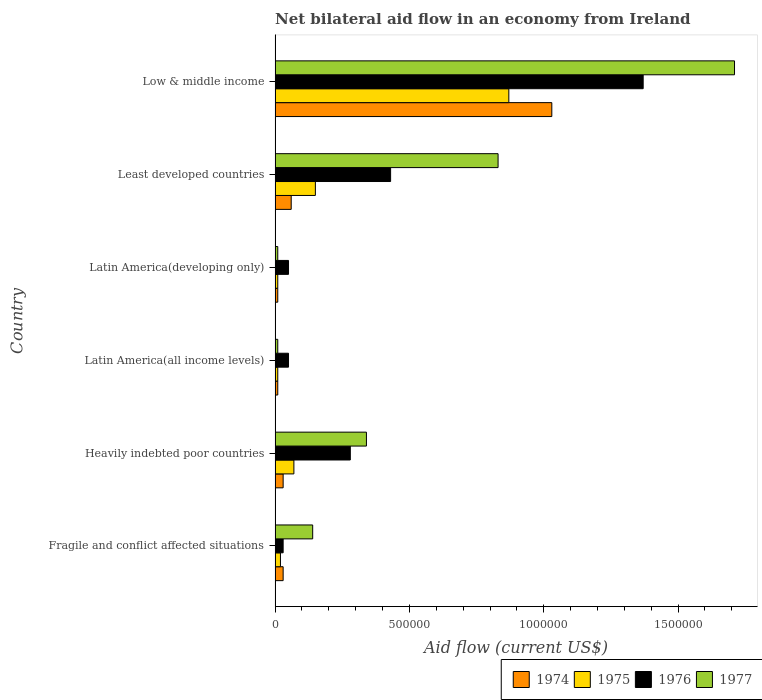How many different coloured bars are there?
Your response must be concise. 4. Are the number of bars per tick equal to the number of legend labels?
Keep it short and to the point. Yes. What is the label of the 1st group of bars from the top?
Provide a succinct answer. Low & middle income. In how many cases, is the number of bars for a given country not equal to the number of legend labels?
Your answer should be compact. 0. Across all countries, what is the maximum net bilateral aid flow in 1974?
Your response must be concise. 1.03e+06. In which country was the net bilateral aid flow in 1977 maximum?
Provide a succinct answer. Low & middle income. In which country was the net bilateral aid flow in 1977 minimum?
Provide a short and direct response. Latin America(all income levels). What is the total net bilateral aid flow in 1977 in the graph?
Ensure brevity in your answer.  3.04e+06. What is the difference between the net bilateral aid flow in 1976 in Fragile and conflict affected situations and that in Least developed countries?
Your answer should be very brief. -4.00e+05. What is the difference between the net bilateral aid flow in 1977 in Latin America(all income levels) and the net bilateral aid flow in 1974 in Least developed countries?
Your response must be concise. -5.00e+04. What is the average net bilateral aid flow in 1976 per country?
Offer a very short reply. 3.68e+05. What is the difference between the net bilateral aid flow in 1977 and net bilateral aid flow in 1975 in Low & middle income?
Give a very brief answer. 8.40e+05. What is the ratio of the net bilateral aid flow in 1974 in Fragile and conflict affected situations to that in Low & middle income?
Make the answer very short. 0.03. Is the net bilateral aid flow in 1976 in Heavily indebted poor countries less than that in Low & middle income?
Offer a very short reply. Yes. What is the difference between the highest and the second highest net bilateral aid flow in 1977?
Provide a succinct answer. 8.80e+05. What is the difference between the highest and the lowest net bilateral aid flow in 1976?
Make the answer very short. 1.34e+06. Is it the case that in every country, the sum of the net bilateral aid flow in 1976 and net bilateral aid flow in 1975 is greater than the sum of net bilateral aid flow in 1974 and net bilateral aid flow in 1977?
Your answer should be very brief. No. What does the 4th bar from the top in Low & middle income represents?
Offer a very short reply. 1974. What does the 3rd bar from the bottom in Fragile and conflict affected situations represents?
Ensure brevity in your answer.  1976. Are all the bars in the graph horizontal?
Provide a succinct answer. Yes. How many countries are there in the graph?
Make the answer very short. 6. What is the difference between two consecutive major ticks on the X-axis?
Provide a short and direct response. 5.00e+05. Are the values on the major ticks of X-axis written in scientific E-notation?
Keep it short and to the point. No. Does the graph contain any zero values?
Your answer should be very brief. No. What is the title of the graph?
Give a very brief answer. Net bilateral aid flow in an economy from Ireland. Does "1981" appear as one of the legend labels in the graph?
Your answer should be very brief. No. What is the Aid flow (current US$) in 1974 in Fragile and conflict affected situations?
Your answer should be compact. 3.00e+04. What is the Aid flow (current US$) of 1977 in Fragile and conflict affected situations?
Your response must be concise. 1.40e+05. What is the Aid flow (current US$) of 1974 in Heavily indebted poor countries?
Offer a terse response. 3.00e+04. What is the Aid flow (current US$) of 1975 in Heavily indebted poor countries?
Offer a very short reply. 7.00e+04. What is the Aid flow (current US$) of 1977 in Heavily indebted poor countries?
Offer a very short reply. 3.40e+05. What is the Aid flow (current US$) in 1974 in Latin America(all income levels)?
Ensure brevity in your answer.  10000. What is the Aid flow (current US$) in 1976 in Latin America(all income levels)?
Your answer should be very brief. 5.00e+04. What is the Aid flow (current US$) in 1977 in Latin America(all income levels)?
Give a very brief answer. 10000. What is the Aid flow (current US$) in 1974 in Latin America(developing only)?
Your answer should be very brief. 10000. What is the Aid flow (current US$) of 1975 in Latin America(developing only)?
Make the answer very short. 10000. What is the Aid flow (current US$) in 1977 in Latin America(developing only)?
Make the answer very short. 10000. What is the Aid flow (current US$) of 1975 in Least developed countries?
Provide a succinct answer. 1.50e+05. What is the Aid flow (current US$) in 1976 in Least developed countries?
Keep it short and to the point. 4.30e+05. What is the Aid flow (current US$) in 1977 in Least developed countries?
Make the answer very short. 8.30e+05. What is the Aid flow (current US$) of 1974 in Low & middle income?
Ensure brevity in your answer.  1.03e+06. What is the Aid flow (current US$) in 1975 in Low & middle income?
Offer a very short reply. 8.70e+05. What is the Aid flow (current US$) in 1976 in Low & middle income?
Your answer should be very brief. 1.37e+06. What is the Aid flow (current US$) in 1977 in Low & middle income?
Provide a short and direct response. 1.71e+06. Across all countries, what is the maximum Aid flow (current US$) in 1974?
Your answer should be compact. 1.03e+06. Across all countries, what is the maximum Aid flow (current US$) in 1975?
Your answer should be very brief. 8.70e+05. Across all countries, what is the maximum Aid flow (current US$) of 1976?
Your answer should be very brief. 1.37e+06. Across all countries, what is the maximum Aid flow (current US$) of 1977?
Provide a succinct answer. 1.71e+06. Across all countries, what is the minimum Aid flow (current US$) in 1976?
Your response must be concise. 3.00e+04. Across all countries, what is the minimum Aid flow (current US$) of 1977?
Offer a terse response. 10000. What is the total Aid flow (current US$) of 1974 in the graph?
Your response must be concise. 1.17e+06. What is the total Aid flow (current US$) in 1975 in the graph?
Provide a succinct answer. 1.13e+06. What is the total Aid flow (current US$) in 1976 in the graph?
Offer a terse response. 2.21e+06. What is the total Aid flow (current US$) in 1977 in the graph?
Your response must be concise. 3.04e+06. What is the difference between the Aid flow (current US$) of 1977 in Fragile and conflict affected situations and that in Heavily indebted poor countries?
Ensure brevity in your answer.  -2.00e+05. What is the difference between the Aid flow (current US$) of 1974 in Fragile and conflict affected situations and that in Latin America(all income levels)?
Your answer should be compact. 2.00e+04. What is the difference between the Aid flow (current US$) of 1975 in Fragile and conflict affected situations and that in Latin America(all income levels)?
Offer a terse response. 10000. What is the difference between the Aid flow (current US$) in 1976 in Fragile and conflict affected situations and that in Latin America(all income levels)?
Provide a short and direct response. -2.00e+04. What is the difference between the Aid flow (current US$) of 1976 in Fragile and conflict affected situations and that in Latin America(developing only)?
Provide a short and direct response. -2.00e+04. What is the difference between the Aid flow (current US$) in 1975 in Fragile and conflict affected situations and that in Least developed countries?
Make the answer very short. -1.30e+05. What is the difference between the Aid flow (current US$) of 1976 in Fragile and conflict affected situations and that in Least developed countries?
Provide a short and direct response. -4.00e+05. What is the difference between the Aid flow (current US$) of 1977 in Fragile and conflict affected situations and that in Least developed countries?
Make the answer very short. -6.90e+05. What is the difference between the Aid flow (current US$) in 1975 in Fragile and conflict affected situations and that in Low & middle income?
Offer a terse response. -8.50e+05. What is the difference between the Aid flow (current US$) of 1976 in Fragile and conflict affected situations and that in Low & middle income?
Your response must be concise. -1.34e+06. What is the difference between the Aid flow (current US$) of 1977 in Fragile and conflict affected situations and that in Low & middle income?
Your answer should be compact. -1.57e+06. What is the difference between the Aid flow (current US$) in 1974 in Heavily indebted poor countries and that in Latin America(all income levels)?
Offer a terse response. 2.00e+04. What is the difference between the Aid flow (current US$) in 1976 in Heavily indebted poor countries and that in Latin America(all income levels)?
Make the answer very short. 2.30e+05. What is the difference between the Aid flow (current US$) of 1977 in Heavily indebted poor countries and that in Latin America(all income levels)?
Provide a short and direct response. 3.30e+05. What is the difference between the Aid flow (current US$) in 1975 in Heavily indebted poor countries and that in Latin America(developing only)?
Your answer should be very brief. 6.00e+04. What is the difference between the Aid flow (current US$) in 1976 in Heavily indebted poor countries and that in Latin America(developing only)?
Offer a terse response. 2.30e+05. What is the difference between the Aid flow (current US$) in 1977 in Heavily indebted poor countries and that in Least developed countries?
Keep it short and to the point. -4.90e+05. What is the difference between the Aid flow (current US$) of 1974 in Heavily indebted poor countries and that in Low & middle income?
Provide a short and direct response. -1.00e+06. What is the difference between the Aid flow (current US$) in 1975 in Heavily indebted poor countries and that in Low & middle income?
Provide a short and direct response. -8.00e+05. What is the difference between the Aid flow (current US$) in 1976 in Heavily indebted poor countries and that in Low & middle income?
Ensure brevity in your answer.  -1.09e+06. What is the difference between the Aid flow (current US$) in 1977 in Heavily indebted poor countries and that in Low & middle income?
Your response must be concise. -1.37e+06. What is the difference between the Aid flow (current US$) in 1974 in Latin America(all income levels) and that in Latin America(developing only)?
Make the answer very short. 0. What is the difference between the Aid flow (current US$) in 1975 in Latin America(all income levels) and that in Latin America(developing only)?
Offer a very short reply. 0. What is the difference between the Aid flow (current US$) of 1974 in Latin America(all income levels) and that in Least developed countries?
Keep it short and to the point. -5.00e+04. What is the difference between the Aid flow (current US$) in 1975 in Latin America(all income levels) and that in Least developed countries?
Your response must be concise. -1.40e+05. What is the difference between the Aid flow (current US$) of 1976 in Latin America(all income levels) and that in Least developed countries?
Ensure brevity in your answer.  -3.80e+05. What is the difference between the Aid flow (current US$) of 1977 in Latin America(all income levels) and that in Least developed countries?
Provide a short and direct response. -8.20e+05. What is the difference between the Aid flow (current US$) in 1974 in Latin America(all income levels) and that in Low & middle income?
Offer a terse response. -1.02e+06. What is the difference between the Aid flow (current US$) in 1975 in Latin America(all income levels) and that in Low & middle income?
Provide a short and direct response. -8.60e+05. What is the difference between the Aid flow (current US$) of 1976 in Latin America(all income levels) and that in Low & middle income?
Provide a succinct answer. -1.32e+06. What is the difference between the Aid flow (current US$) of 1977 in Latin America(all income levels) and that in Low & middle income?
Offer a terse response. -1.70e+06. What is the difference between the Aid flow (current US$) of 1974 in Latin America(developing only) and that in Least developed countries?
Your answer should be very brief. -5.00e+04. What is the difference between the Aid flow (current US$) in 1976 in Latin America(developing only) and that in Least developed countries?
Offer a very short reply. -3.80e+05. What is the difference between the Aid flow (current US$) of 1977 in Latin America(developing only) and that in Least developed countries?
Ensure brevity in your answer.  -8.20e+05. What is the difference between the Aid flow (current US$) in 1974 in Latin America(developing only) and that in Low & middle income?
Your answer should be very brief. -1.02e+06. What is the difference between the Aid flow (current US$) in 1975 in Latin America(developing only) and that in Low & middle income?
Provide a short and direct response. -8.60e+05. What is the difference between the Aid flow (current US$) of 1976 in Latin America(developing only) and that in Low & middle income?
Make the answer very short. -1.32e+06. What is the difference between the Aid flow (current US$) of 1977 in Latin America(developing only) and that in Low & middle income?
Ensure brevity in your answer.  -1.70e+06. What is the difference between the Aid flow (current US$) in 1974 in Least developed countries and that in Low & middle income?
Ensure brevity in your answer.  -9.70e+05. What is the difference between the Aid flow (current US$) in 1975 in Least developed countries and that in Low & middle income?
Ensure brevity in your answer.  -7.20e+05. What is the difference between the Aid flow (current US$) in 1976 in Least developed countries and that in Low & middle income?
Keep it short and to the point. -9.40e+05. What is the difference between the Aid flow (current US$) of 1977 in Least developed countries and that in Low & middle income?
Ensure brevity in your answer.  -8.80e+05. What is the difference between the Aid flow (current US$) in 1974 in Fragile and conflict affected situations and the Aid flow (current US$) in 1975 in Heavily indebted poor countries?
Your answer should be very brief. -4.00e+04. What is the difference between the Aid flow (current US$) of 1974 in Fragile and conflict affected situations and the Aid flow (current US$) of 1977 in Heavily indebted poor countries?
Give a very brief answer. -3.10e+05. What is the difference between the Aid flow (current US$) of 1975 in Fragile and conflict affected situations and the Aid flow (current US$) of 1976 in Heavily indebted poor countries?
Provide a succinct answer. -2.60e+05. What is the difference between the Aid flow (current US$) in 1975 in Fragile and conflict affected situations and the Aid flow (current US$) in 1977 in Heavily indebted poor countries?
Your response must be concise. -3.20e+05. What is the difference between the Aid flow (current US$) of 1976 in Fragile and conflict affected situations and the Aid flow (current US$) of 1977 in Heavily indebted poor countries?
Provide a succinct answer. -3.10e+05. What is the difference between the Aid flow (current US$) of 1974 in Fragile and conflict affected situations and the Aid flow (current US$) of 1975 in Latin America(all income levels)?
Offer a terse response. 2.00e+04. What is the difference between the Aid flow (current US$) of 1974 in Fragile and conflict affected situations and the Aid flow (current US$) of 1976 in Latin America(all income levels)?
Give a very brief answer. -2.00e+04. What is the difference between the Aid flow (current US$) of 1975 in Fragile and conflict affected situations and the Aid flow (current US$) of 1976 in Latin America(all income levels)?
Your answer should be very brief. -3.00e+04. What is the difference between the Aid flow (current US$) in 1975 in Fragile and conflict affected situations and the Aid flow (current US$) in 1977 in Latin America(all income levels)?
Make the answer very short. 10000. What is the difference between the Aid flow (current US$) of 1975 in Fragile and conflict affected situations and the Aid flow (current US$) of 1977 in Latin America(developing only)?
Provide a succinct answer. 10000. What is the difference between the Aid flow (current US$) in 1976 in Fragile and conflict affected situations and the Aid flow (current US$) in 1977 in Latin America(developing only)?
Provide a succinct answer. 2.00e+04. What is the difference between the Aid flow (current US$) of 1974 in Fragile and conflict affected situations and the Aid flow (current US$) of 1975 in Least developed countries?
Your answer should be very brief. -1.20e+05. What is the difference between the Aid flow (current US$) in 1974 in Fragile and conflict affected situations and the Aid flow (current US$) in 1976 in Least developed countries?
Your answer should be very brief. -4.00e+05. What is the difference between the Aid flow (current US$) in 1974 in Fragile and conflict affected situations and the Aid flow (current US$) in 1977 in Least developed countries?
Offer a very short reply. -8.00e+05. What is the difference between the Aid flow (current US$) in 1975 in Fragile and conflict affected situations and the Aid flow (current US$) in 1976 in Least developed countries?
Provide a succinct answer. -4.10e+05. What is the difference between the Aid flow (current US$) of 1975 in Fragile and conflict affected situations and the Aid flow (current US$) of 1977 in Least developed countries?
Keep it short and to the point. -8.10e+05. What is the difference between the Aid flow (current US$) in 1976 in Fragile and conflict affected situations and the Aid flow (current US$) in 1977 in Least developed countries?
Offer a terse response. -8.00e+05. What is the difference between the Aid flow (current US$) of 1974 in Fragile and conflict affected situations and the Aid flow (current US$) of 1975 in Low & middle income?
Provide a short and direct response. -8.40e+05. What is the difference between the Aid flow (current US$) in 1974 in Fragile and conflict affected situations and the Aid flow (current US$) in 1976 in Low & middle income?
Give a very brief answer. -1.34e+06. What is the difference between the Aid flow (current US$) in 1974 in Fragile and conflict affected situations and the Aid flow (current US$) in 1977 in Low & middle income?
Your answer should be very brief. -1.68e+06. What is the difference between the Aid flow (current US$) of 1975 in Fragile and conflict affected situations and the Aid flow (current US$) of 1976 in Low & middle income?
Provide a succinct answer. -1.35e+06. What is the difference between the Aid flow (current US$) in 1975 in Fragile and conflict affected situations and the Aid flow (current US$) in 1977 in Low & middle income?
Your response must be concise. -1.69e+06. What is the difference between the Aid flow (current US$) of 1976 in Fragile and conflict affected situations and the Aid flow (current US$) of 1977 in Low & middle income?
Make the answer very short. -1.68e+06. What is the difference between the Aid flow (current US$) of 1974 in Heavily indebted poor countries and the Aid flow (current US$) of 1977 in Latin America(all income levels)?
Provide a short and direct response. 2.00e+04. What is the difference between the Aid flow (current US$) of 1975 in Heavily indebted poor countries and the Aid flow (current US$) of 1977 in Latin America(all income levels)?
Ensure brevity in your answer.  6.00e+04. What is the difference between the Aid flow (current US$) of 1975 in Heavily indebted poor countries and the Aid flow (current US$) of 1976 in Latin America(developing only)?
Give a very brief answer. 2.00e+04. What is the difference between the Aid flow (current US$) of 1976 in Heavily indebted poor countries and the Aid flow (current US$) of 1977 in Latin America(developing only)?
Give a very brief answer. 2.70e+05. What is the difference between the Aid flow (current US$) in 1974 in Heavily indebted poor countries and the Aid flow (current US$) in 1976 in Least developed countries?
Give a very brief answer. -4.00e+05. What is the difference between the Aid flow (current US$) of 1974 in Heavily indebted poor countries and the Aid flow (current US$) of 1977 in Least developed countries?
Give a very brief answer. -8.00e+05. What is the difference between the Aid flow (current US$) of 1975 in Heavily indebted poor countries and the Aid flow (current US$) of 1976 in Least developed countries?
Your answer should be very brief. -3.60e+05. What is the difference between the Aid flow (current US$) of 1975 in Heavily indebted poor countries and the Aid flow (current US$) of 1977 in Least developed countries?
Your answer should be very brief. -7.60e+05. What is the difference between the Aid flow (current US$) of 1976 in Heavily indebted poor countries and the Aid flow (current US$) of 1977 in Least developed countries?
Offer a terse response. -5.50e+05. What is the difference between the Aid flow (current US$) in 1974 in Heavily indebted poor countries and the Aid flow (current US$) in 1975 in Low & middle income?
Keep it short and to the point. -8.40e+05. What is the difference between the Aid flow (current US$) of 1974 in Heavily indebted poor countries and the Aid flow (current US$) of 1976 in Low & middle income?
Your response must be concise. -1.34e+06. What is the difference between the Aid flow (current US$) in 1974 in Heavily indebted poor countries and the Aid flow (current US$) in 1977 in Low & middle income?
Give a very brief answer. -1.68e+06. What is the difference between the Aid flow (current US$) in 1975 in Heavily indebted poor countries and the Aid flow (current US$) in 1976 in Low & middle income?
Provide a succinct answer. -1.30e+06. What is the difference between the Aid flow (current US$) in 1975 in Heavily indebted poor countries and the Aid flow (current US$) in 1977 in Low & middle income?
Make the answer very short. -1.64e+06. What is the difference between the Aid flow (current US$) of 1976 in Heavily indebted poor countries and the Aid flow (current US$) of 1977 in Low & middle income?
Provide a short and direct response. -1.43e+06. What is the difference between the Aid flow (current US$) in 1975 in Latin America(all income levels) and the Aid flow (current US$) in 1977 in Latin America(developing only)?
Give a very brief answer. 0. What is the difference between the Aid flow (current US$) of 1974 in Latin America(all income levels) and the Aid flow (current US$) of 1975 in Least developed countries?
Your answer should be very brief. -1.40e+05. What is the difference between the Aid flow (current US$) in 1974 in Latin America(all income levels) and the Aid flow (current US$) in 1976 in Least developed countries?
Provide a short and direct response. -4.20e+05. What is the difference between the Aid flow (current US$) in 1974 in Latin America(all income levels) and the Aid flow (current US$) in 1977 in Least developed countries?
Offer a terse response. -8.20e+05. What is the difference between the Aid flow (current US$) of 1975 in Latin America(all income levels) and the Aid flow (current US$) of 1976 in Least developed countries?
Provide a short and direct response. -4.20e+05. What is the difference between the Aid flow (current US$) in 1975 in Latin America(all income levels) and the Aid flow (current US$) in 1977 in Least developed countries?
Keep it short and to the point. -8.20e+05. What is the difference between the Aid flow (current US$) in 1976 in Latin America(all income levels) and the Aid flow (current US$) in 1977 in Least developed countries?
Your answer should be compact. -7.80e+05. What is the difference between the Aid flow (current US$) of 1974 in Latin America(all income levels) and the Aid flow (current US$) of 1975 in Low & middle income?
Offer a terse response. -8.60e+05. What is the difference between the Aid flow (current US$) in 1974 in Latin America(all income levels) and the Aid flow (current US$) in 1976 in Low & middle income?
Offer a very short reply. -1.36e+06. What is the difference between the Aid flow (current US$) in 1974 in Latin America(all income levels) and the Aid flow (current US$) in 1977 in Low & middle income?
Your answer should be very brief. -1.70e+06. What is the difference between the Aid flow (current US$) of 1975 in Latin America(all income levels) and the Aid flow (current US$) of 1976 in Low & middle income?
Keep it short and to the point. -1.36e+06. What is the difference between the Aid flow (current US$) in 1975 in Latin America(all income levels) and the Aid flow (current US$) in 1977 in Low & middle income?
Your answer should be compact. -1.70e+06. What is the difference between the Aid flow (current US$) in 1976 in Latin America(all income levels) and the Aid flow (current US$) in 1977 in Low & middle income?
Offer a terse response. -1.66e+06. What is the difference between the Aid flow (current US$) of 1974 in Latin America(developing only) and the Aid flow (current US$) of 1976 in Least developed countries?
Provide a short and direct response. -4.20e+05. What is the difference between the Aid flow (current US$) of 1974 in Latin America(developing only) and the Aid flow (current US$) of 1977 in Least developed countries?
Your answer should be compact. -8.20e+05. What is the difference between the Aid flow (current US$) of 1975 in Latin America(developing only) and the Aid flow (current US$) of 1976 in Least developed countries?
Your response must be concise. -4.20e+05. What is the difference between the Aid flow (current US$) in 1975 in Latin America(developing only) and the Aid flow (current US$) in 1977 in Least developed countries?
Provide a short and direct response. -8.20e+05. What is the difference between the Aid flow (current US$) of 1976 in Latin America(developing only) and the Aid flow (current US$) of 1977 in Least developed countries?
Ensure brevity in your answer.  -7.80e+05. What is the difference between the Aid flow (current US$) of 1974 in Latin America(developing only) and the Aid flow (current US$) of 1975 in Low & middle income?
Your answer should be very brief. -8.60e+05. What is the difference between the Aid flow (current US$) of 1974 in Latin America(developing only) and the Aid flow (current US$) of 1976 in Low & middle income?
Your answer should be compact. -1.36e+06. What is the difference between the Aid flow (current US$) in 1974 in Latin America(developing only) and the Aid flow (current US$) in 1977 in Low & middle income?
Give a very brief answer. -1.70e+06. What is the difference between the Aid flow (current US$) of 1975 in Latin America(developing only) and the Aid flow (current US$) of 1976 in Low & middle income?
Provide a short and direct response. -1.36e+06. What is the difference between the Aid flow (current US$) of 1975 in Latin America(developing only) and the Aid flow (current US$) of 1977 in Low & middle income?
Ensure brevity in your answer.  -1.70e+06. What is the difference between the Aid flow (current US$) of 1976 in Latin America(developing only) and the Aid flow (current US$) of 1977 in Low & middle income?
Your answer should be very brief. -1.66e+06. What is the difference between the Aid flow (current US$) of 1974 in Least developed countries and the Aid flow (current US$) of 1975 in Low & middle income?
Your response must be concise. -8.10e+05. What is the difference between the Aid flow (current US$) of 1974 in Least developed countries and the Aid flow (current US$) of 1976 in Low & middle income?
Offer a very short reply. -1.31e+06. What is the difference between the Aid flow (current US$) of 1974 in Least developed countries and the Aid flow (current US$) of 1977 in Low & middle income?
Your answer should be compact. -1.65e+06. What is the difference between the Aid flow (current US$) in 1975 in Least developed countries and the Aid flow (current US$) in 1976 in Low & middle income?
Offer a terse response. -1.22e+06. What is the difference between the Aid flow (current US$) of 1975 in Least developed countries and the Aid flow (current US$) of 1977 in Low & middle income?
Provide a succinct answer. -1.56e+06. What is the difference between the Aid flow (current US$) of 1976 in Least developed countries and the Aid flow (current US$) of 1977 in Low & middle income?
Offer a very short reply. -1.28e+06. What is the average Aid flow (current US$) of 1974 per country?
Provide a succinct answer. 1.95e+05. What is the average Aid flow (current US$) in 1975 per country?
Provide a short and direct response. 1.88e+05. What is the average Aid flow (current US$) in 1976 per country?
Offer a terse response. 3.68e+05. What is the average Aid flow (current US$) of 1977 per country?
Give a very brief answer. 5.07e+05. What is the difference between the Aid flow (current US$) of 1974 and Aid flow (current US$) of 1975 in Fragile and conflict affected situations?
Your answer should be very brief. 10000. What is the difference between the Aid flow (current US$) in 1975 and Aid flow (current US$) in 1976 in Fragile and conflict affected situations?
Your answer should be very brief. -10000. What is the difference between the Aid flow (current US$) in 1975 and Aid flow (current US$) in 1977 in Fragile and conflict affected situations?
Ensure brevity in your answer.  -1.20e+05. What is the difference between the Aid flow (current US$) of 1976 and Aid flow (current US$) of 1977 in Fragile and conflict affected situations?
Your answer should be compact. -1.10e+05. What is the difference between the Aid flow (current US$) of 1974 and Aid flow (current US$) of 1977 in Heavily indebted poor countries?
Provide a succinct answer. -3.10e+05. What is the difference between the Aid flow (current US$) in 1975 and Aid flow (current US$) in 1976 in Heavily indebted poor countries?
Make the answer very short. -2.10e+05. What is the difference between the Aid flow (current US$) in 1975 and Aid flow (current US$) in 1977 in Heavily indebted poor countries?
Offer a terse response. -2.70e+05. What is the difference between the Aid flow (current US$) in 1976 and Aid flow (current US$) in 1977 in Heavily indebted poor countries?
Keep it short and to the point. -6.00e+04. What is the difference between the Aid flow (current US$) of 1975 and Aid flow (current US$) of 1977 in Latin America(all income levels)?
Your answer should be compact. 0. What is the difference between the Aid flow (current US$) in 1976 and Aid flow (current US$) in 1977 in Latin America(all income levels)?
Provide a short and direct response. 4.00e+04. What is the difference between the Aid flow (current US$) in 1975 and Aid flow (current US$) in 1976 in Latin America(developing only)?
Your answer should be very brief. -4.00e+04. What is the difference between the Aid flow (current US$) in 1975 and Aid flow (current US$) in 1977 in Latin America(developing only)?
Ensure brevity in your answer.  0. What is the difference between the Aid flow (current US$) of 1976 and Aid flow (current US$) of 1977 in Latin America(developing only)?
Make the answer very short. 4.00e+04. What is the difference between the Aid flow (current US$) in 1974 and Aid flow (current US$) in 1975 in Least developed countries?
Give a very brief answer. -9.00e+04. What is the difference between the Aid flow (current US$) in 1974 and Aid flow (current US$) in 1976 in Least developed countries?
Give a very brief answer. -3.70e+05. What is the difference between the Aid flow (current US$) of 1974 and Aid flow (current US$) of 1977 in Least developed countries?
Your response must be concise. -7.70e+05. What is the difference between the Aid flow (current US$) in 1975 and Aid flow (current US$) in 1976 in Least developed countries?
Ensure brevity in your answer.  -2.80e+05. What is the difference between the Aid flow (current US$) of 1975 and Aid flow (current US$) of 1977 in Least developed countries?
Give a very brief answer. -6.80e+05. What is the difference between the Aid flow (current US$) of 1976 and Aid flow (current US$) of 1977 in Least developed countries?
Your answer should be very brief. -4.00e+05. What is the difference between the Aid flow (current US$) of 1974 and Aid flow (current US$) of 1977 in Low & middle income?
Keep it short and to the point. -6.80e+05. What is the difference between the Aid flow (current US$) of 1975 and Aid flow (current US$) of 1976 in Low & middle income?
Give a very brief answer. -5.00e+05. What is the difference between the Aid flow (current US$) of 1975 and Aid flow (current US$) of 1977 in Low & middle income?
Your answer should be compact. -8.40e+05. What is the ratio of the Aid flow (current US$) of 1975 in Fragile and conflict affected situations to that in Heavily indebted poor countries?
Provide a succinct answer. 0.29. What is the ratio of the Aid flow (current US$) of 1976 in Fragile and conflict affected situations to that in Heavily indebted poor countries?
Your answer should be very brief. 0.11. What is the ratio of the Aid flow (current US$) of 1977 in Fragile and conflict affected situations to that in Heavily indebted poor countries?
Your response must be concise. 0.41. What is the ratio of the Aid flow (current US$) in 1974 in Fragile and conflict affected situations to that in Latin America(all income levels)?
Make the answer very short. 3. What is the ratio of the Aid flow (current US$) in 1974 in Fragile and conflict affected situations to that in Latin America(developing only)?
Keep it short and to the point. 3. What is the ratio of the Aid flow (current US$) in 1977 in Fragile and conflict affected situations to that in Latin America(developing only)?
Give a very brief answer. 14. What is the ratio of the Aid flow (current US$) in 1974 in Fragile and conflict affected situations to that in Least developed countries?
Offer a terse response. 0.5. What is the ratio of the Aid flow (current US$) of 1975 in Fragile and conflict affected situations to that in Least developed countries?
Keep it short and to the point. 0.13. What is the ratio of the Aid flow (current US$) of 1976 in Fragile and conflict affected situations to that in Least developed countries?
Your response must be concise. 0.07. What is the ratio of the Aid flow (current US$) in 1977 in Fragile and conflict affected situations to that in Least developed countries?
Provide a succinct answer. 0.17. What is the ratio of the Aid flow (current US$) of 1974 in Fragile and conflict affected situations to that in Low & middle income?
Make the answer very short. 0.03. What is the ratio of the Aid flow (current US$) in 1975 in Fragile and conflict affected situations to that in Low & middle income?
Make the answer very short. 0.02. What is the ratio of the Aid flow (current US$) in 1976 in Fragile and conflict affected situations to that in Low & middle income?
Provide a succinct answer. 0.02. What is the ratio of the Aid flow (current US$) in 1977 in Fragile and conflict affected situations to that in Low & middle income?
Your answer should be compact. 0.08. What is the ratio of the Aid flow (current US$) of 1974 in Heavily indebted poor countries to that in Latin America(all income levels)?
Ensure brevity in your answer.  3. What is the ratio of the Aid flow (current US$) of 1976 in Heavily indebted poor countries to that in Latin America(all income levels)?
Provide a short and direct response. 5.6. What is the ratio of the Aid flow (current US$) in 1974 in Heavily indebted poor countries to that in Latin America(developing only)?
Keep it short and to the point. 3. What is the ratio of the Aid flow (current US$) in 1975 in Heavily indebted poor countries to that in Latin America(developing only)?
Your answer should be compact. 7. What is the ratio of the Aid flow (current US$) in 1975 in Heavily indebted poor countries to that in Least developed countries?
Provide a short and direct response. 0.47. What is the ratio of the Aid flow (current US$) of 1976 in Heavily indebted poor countries to that in Least developed countries?
Offer a terse response. 0.65. What is the ratio of the Aid flow (current US$) in 1977 in Heavily indebted poor countries to that in Least developed countries?
Ensure brevity in your answer.  0.41. What is the ratio of the Aid flow (current US$) in 1974 in Heavily indebted poor countries to that in Low & middle income?
Your answer should be compact. 0.03. What is the ratio of the Aid flow (current US$) in 1975 in Heavily indebted poor countries to that in Low & middle income?
Offer a very short reply. 0.08. What is the ratio of the Aid flow (current US$) in 1976 in Heavily indebted poor countries to that in Low & middle income?
Offer a very short reply. 0.2. What is the ratio of the Aid flow (current US$) in 1977 in Heavily indebted poor countries to that in Low & middle income?
Your response must be concise. 0.2. What is the ratio of the Aid flow (current US$) in 1974 in Latin America(all income levels) to that in Latin America(developing only)?
Your answer should be compact. 1. What is the ratio of the Aid flow (current US$) in 1977 in Latin America(all income levels) to that in Latin America(developing only)?
Offer a terse response. 1. What is the ratio of the Aid flow (current US$) of 1974 in Latin America(all income levels) to that in Least developed countries?
Give a very brief answer. 0.17. What is the ratio of the Aid flow (current US$) in 1975 in Latin America(all income levels) to that in Least developed countries?
Your answer should be compact. 0.07. What is the ratio of the Aid flow (current US$) in 1976 in Latin America(all income levels) to that in Least developed countries?
Provide a succinct answer. 0.12. What is the ratio of the Aid flow (current US$) in 1977 in Latin America(all income levels) to that in Least developed countries?
Give a very brief answer. 0.01. What is the ratio of the Aid flow (current US$) of 1974 in Latin America(all income levels) to that in Low & middle income?
Offer a very short reply. 0.01. What is the ratio of the Aid flow (current US$) of 1975 in Latin America(all income levels) to that in Low & middle income?
Your response must be concise. 0.01. What is the ratio of the Aid flow (current US$) in 1976 in Latin America(all income levels) to that in Low & middle income?
Offer a terse response. 0.04. What is the ratio of the Aid flow (current US$) in 1977 in Latin America(all income levels) to that in Low & middle income?
Offer a very short reply. 0.01. What is the ratio of the Aid flow (current US$) of 1975 in Latin America(developing only) to that in Least developed countries?
Your response must be concise. 0.07. What is the ratio of the Aid flow (current US$) in 1976 in Latin America(developing only) to that in Least developed countries?
Ensure brevity in your answer.  0.12. What is the ratio of the Aid flow (current US$) in 1977 in Latin America(developing only) to that in Least developed countries?
Keep it short and to the point. 0.01. What is the ratio of the Aid flow (current US$) in 1974 in Latin America(developing only) to that in Low & middle income?
Ensure brevity in your answer.  0.01. What is the ratio of the Aid flow (current US$) in 1975 in Latin America(developing only) to that in Low & middle income?
Offer a very short reply. 0.01. What is the ratio of the Aid flow (current US$) in 1976 in Latin America(developing only) to that in Low & middle income?
Keep it short and to the point. 0.04. What is the ratio of the Aid flow (current US$) of 1977 in Latin America(developing only) to that in Low & middle income?
Give a very brief answer. 0.01. What is the ratio of the Aid flow (current US$) in 1974 in Least developed countries to that in Low & middle income?
Keep it short and to the point. 0.06. What is the ratio of the Aid flow (current US$) in 1975 in Least developed countries to that in Low & middle income?
Give a very brief answer. 0.17. What is the ratio of the Aid flow (current US$) of 1976 in Least developed countries to that in Low & middle income?
Ensure brevity in your answer.  0.31. What is the ratio of the Aid flow (current US$) in 1977 in Least developed countries to that in Low & middle income?
Provide a succinct answer. 0.49. What is the difference between the highest and the second highest Aid flow (current US$) of 1974?
Offer a terse response. 9.70e+05. What is the difference between the highest and the second highest Aid flow (current US$) in 1975?
Ensure brevity in your answer.  7.20e+05. What is the difference between the highest and the second highest Aid flow (current US$) in 1976?
Your answer should be compact. 9.40e+05. What is the difference between the highest and the second highest Aid flow (current US$) of 1977?
Your response must be concise. 8.80e+05. What is the difference between the highest and the lowest Aid flow (current US$) in 1974?
Your response must be concise. 1.02e+06. What is the difference between the highest and the lowest Aid flow (current US$) in 1975?
Your answer should be very brief. 8.60e+05. What is the difference between the highest and the lowest Aid flow (current US$) in 1976?
Your answer should be very brief. 1.34e+06. What is the difference between the highest and the lowest Aid flow (current US$) in 1977?
Your answer should be very brief. 1.70e+06. 